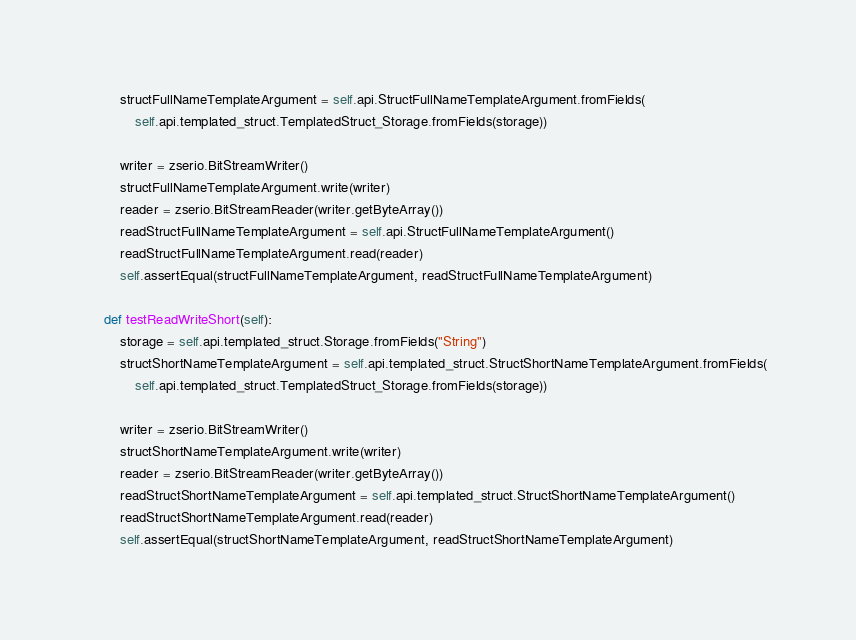Convert code to text. <code><loc_0><loc_0><loc_500><loc_500><_Python_>        structFullNameTemplateArgument = self.api.StructFullNameTemplateArgument.fromFields(
            self.api.templated_struct.TemplatedStruct_Storage.fromFields(storage))

        writer = zserio.BitStreamWriter()
        structFullNameTemplateArgument.write(writer)
        reader = zserio.BitStreamReader(writer.getByteArray())
        readStructFullNameTemplateArgument = self.api.StructFullNameTemplateArgument()
        readStructFullNameTemplateArgument.read(reader)
        self.assertEqual(structFullNameTemplateArgument, readStructFullNameTemplateArgument)

    def testReadWriteShort(self):
        storage = self.api.templated_struct.Storage.fromFields("String")
        structShortNameTemplateArgument = self.api.templated_struct.StructShortNameTemplateArgument.fromFields(
            self.api.templated_struct.TemplatedStruct_Storage.fromFields(storage))

        writer = zserio.BitStreamWriter()
        structShortNameTemplateArgument.write(writer)
        reader = zserio.BitStreamReader(writer.getByteArray())
        readStructShortNameTemplateArgument = self.api.templated_struct.StructShortNameTemplateArgument()
        readStructShortNameTemplateArgument.read(reader)
        self.assertEqual(structShortNameTemplateArgument, readStructShortNameTemplateArgument)
</code> 